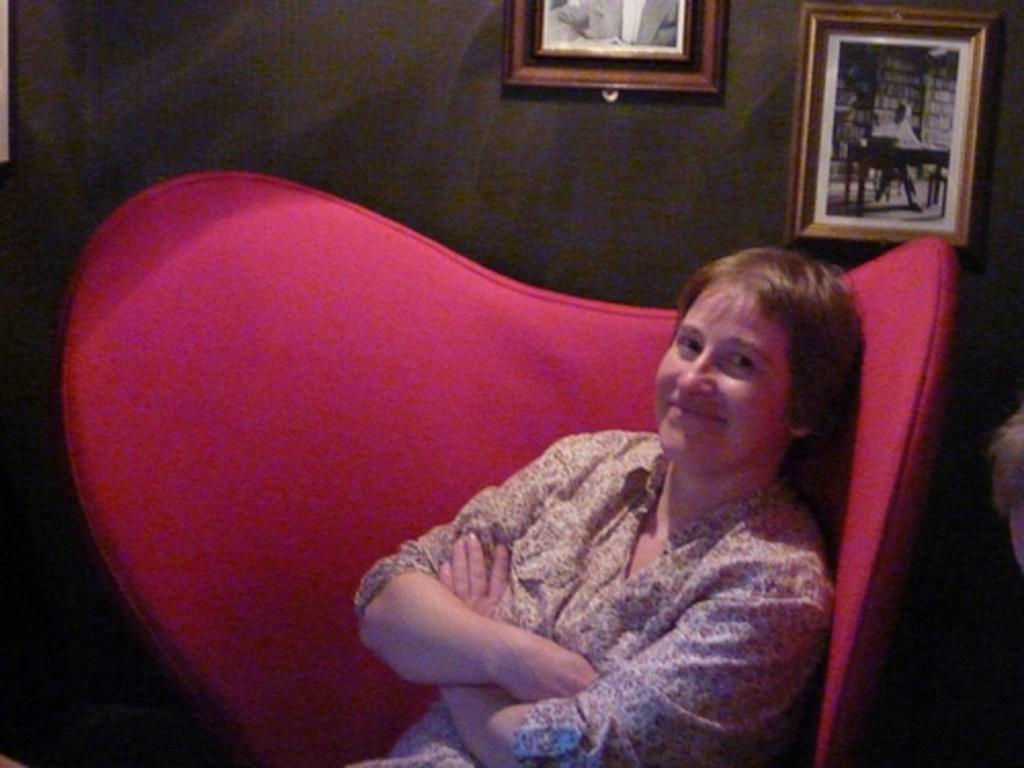Who is present in the image? There is a woman in the image. What is the woman doing in the image? The woman is sitting in the image. What is the woman's facial expression in the image? The woman is smiling in the image. Where is the woman sitting in the image? The woman is sitting on a sofa in the image. What can be seen on the wall in the background of the image? There are photo frames on the wall in the background of the image. How does the woman's nervous system function in the image? The image does not provide information about the woman's nervous system, so it cannot be determined from the image. 